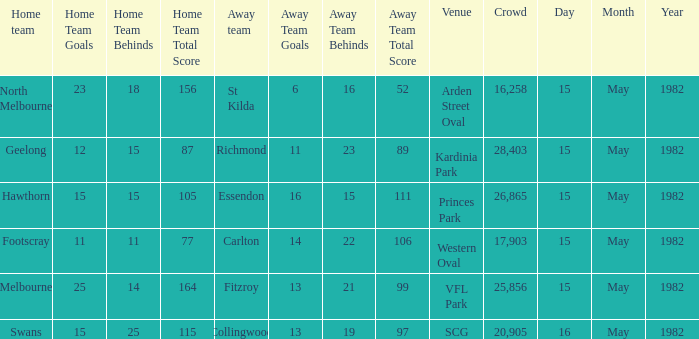Where did North Melbourne play as the home team? Arden Street Oval. 